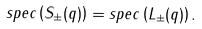Convert formula to latex. <formula><loc_0><loc_0><loc_500><loc_500>s p e c \left ( S _ { \pm } ( q ) \right ) = s p e c \left ( L _ { \pm } ( q ) \right ) .</formula> 